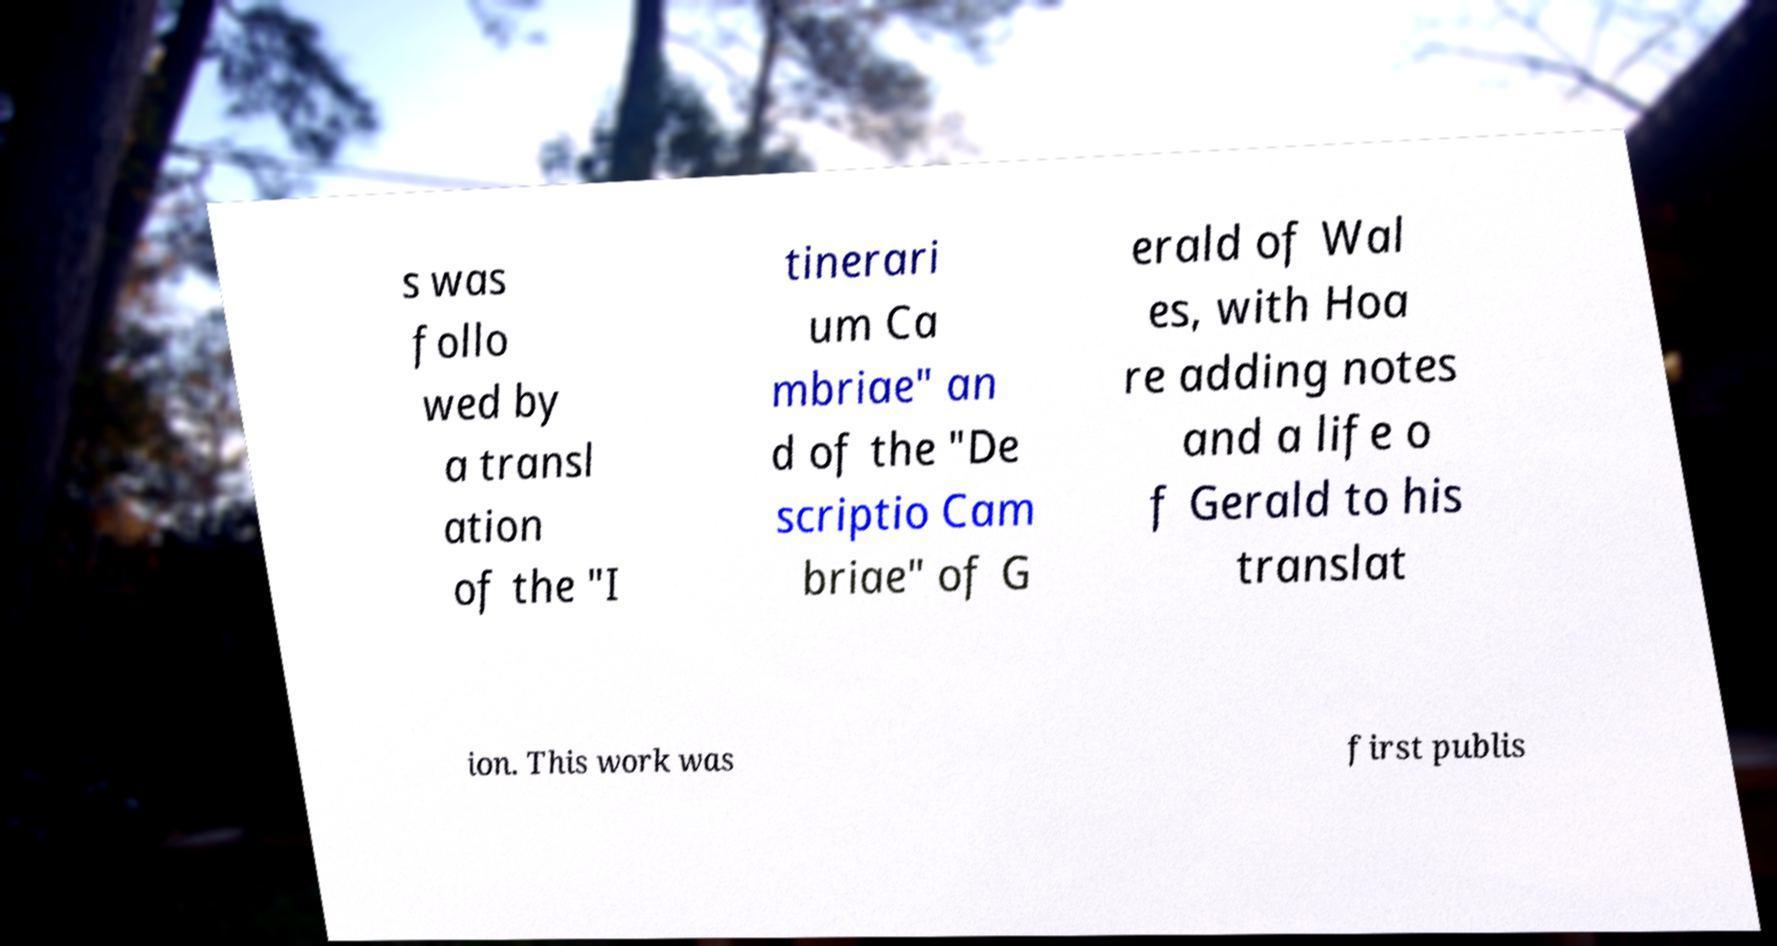Please read and relay the text visible in this image. What does it say? s was follo wed by a transl ation of the "I tinerari um Ca mbriae" an d of the "De scriptio Cam briae" of G erald of Wal es, with Hoa re adding notes and a life o f Gerald to his translat ion. This work was first publis 